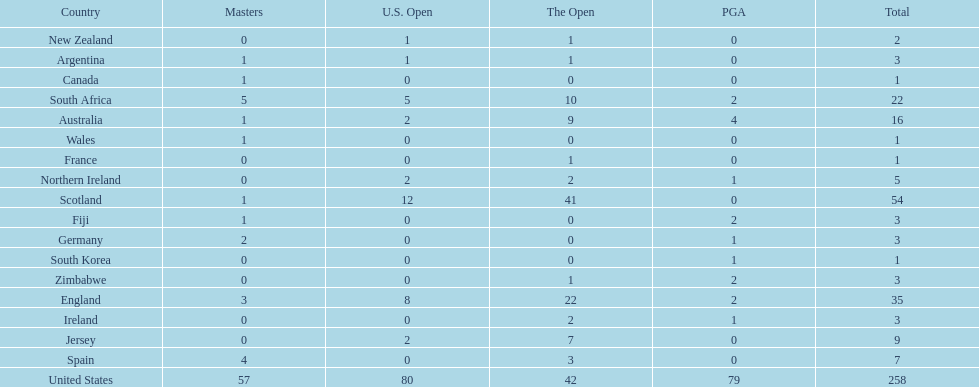How many u.s. open wins does fiji have? 0. 